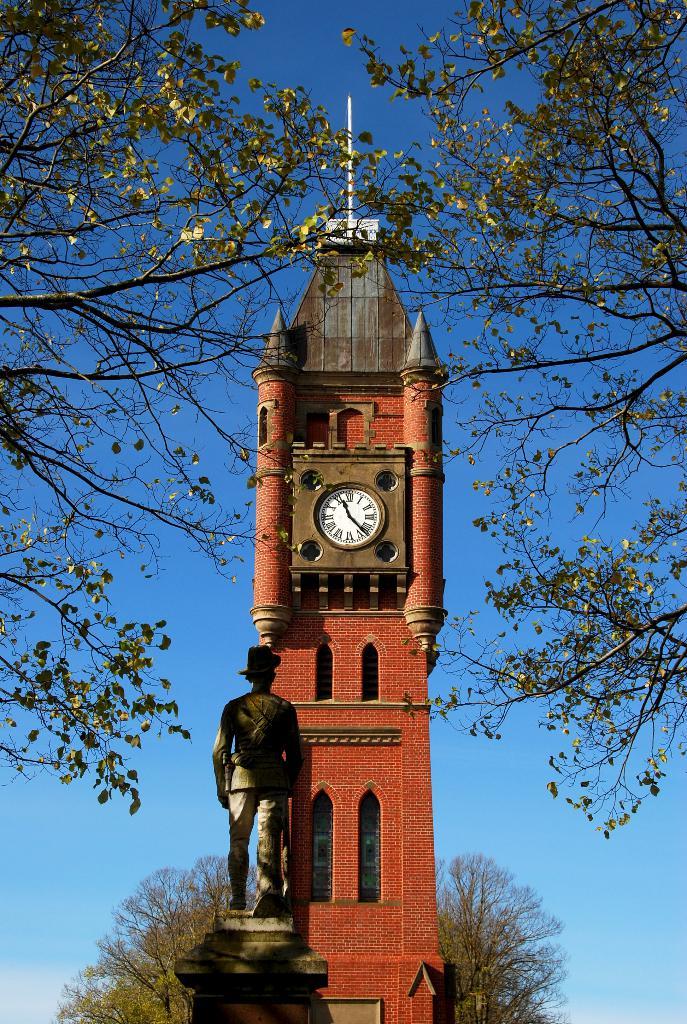What time is it?
Offer a terse response. 11:22. What gender is the statue?
Make the answer very short. Answering does not require reading text in the image. 